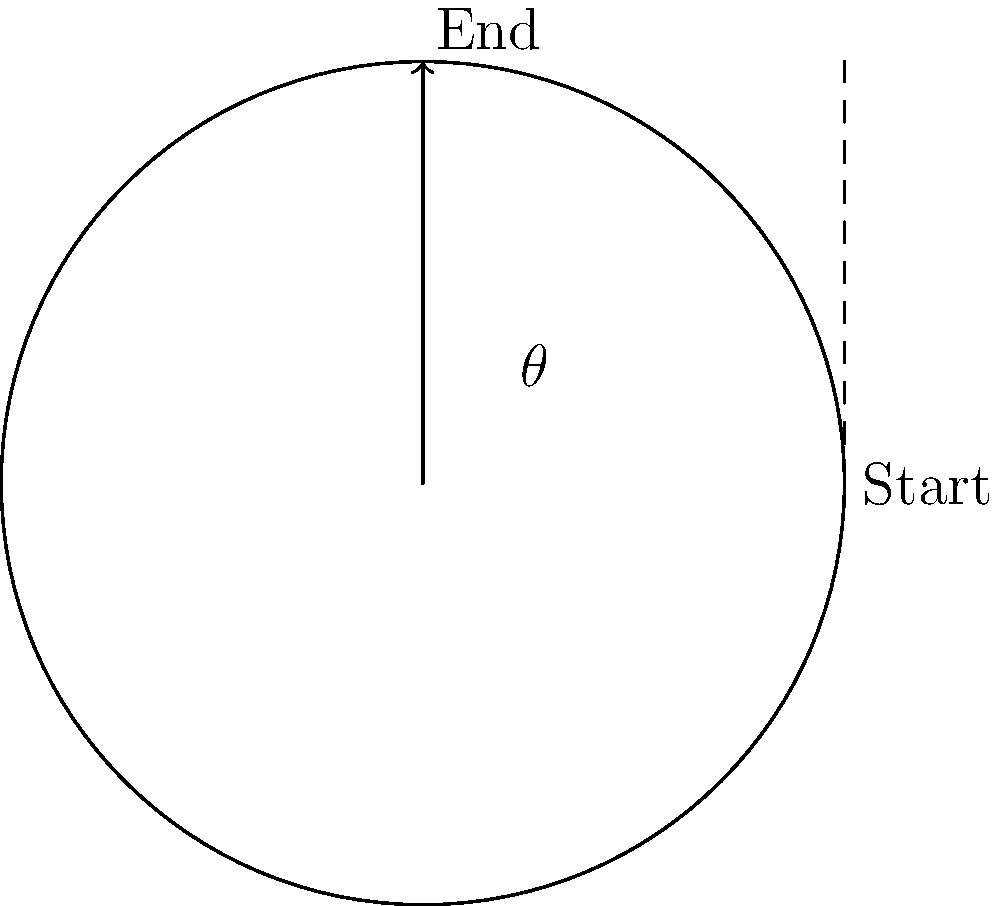A vinyl record featuring Kris Dollimore's music rotates through an angle $\theta$ as shown in the diagram. If the record completes one full rotation in 1.8 seconds, how long does it take to rotate through the angle $\theta$? To solve this problem, let's follow these steps:

1) First, we need to identify the angle $\theta$ in the diagram. It appears to be a quarter turn, which is $\frac{\pi}{2}$ radians or 90°.

2) We know that one full rotation of the record takes 1.8 seconds. A full rotation is $2\pi$ radians or 360°.

3) We can set up a proportion:
   $$\frac{2\pi \text{ radians}}{1.8 \text{ seconds}} = \frac{\frac{\pi}{2} \text{ radians}}{x \text{ seconds}}$$

4) Cross multiply:
   $$2\pi x = 1.8 \cdot \frac{\pi}{2}$$

5) Simplify:
   $$2\pi x = 0.9\pi$$

6) Divide both sides by $2\pi$:
   $$x = \frac{0.9\pi}{2\pi} = 0.45$$

Therefore, it takes 0.45 seconds for the record to rotate through the angle $\theta$.
Answer: 0.45 seconds 